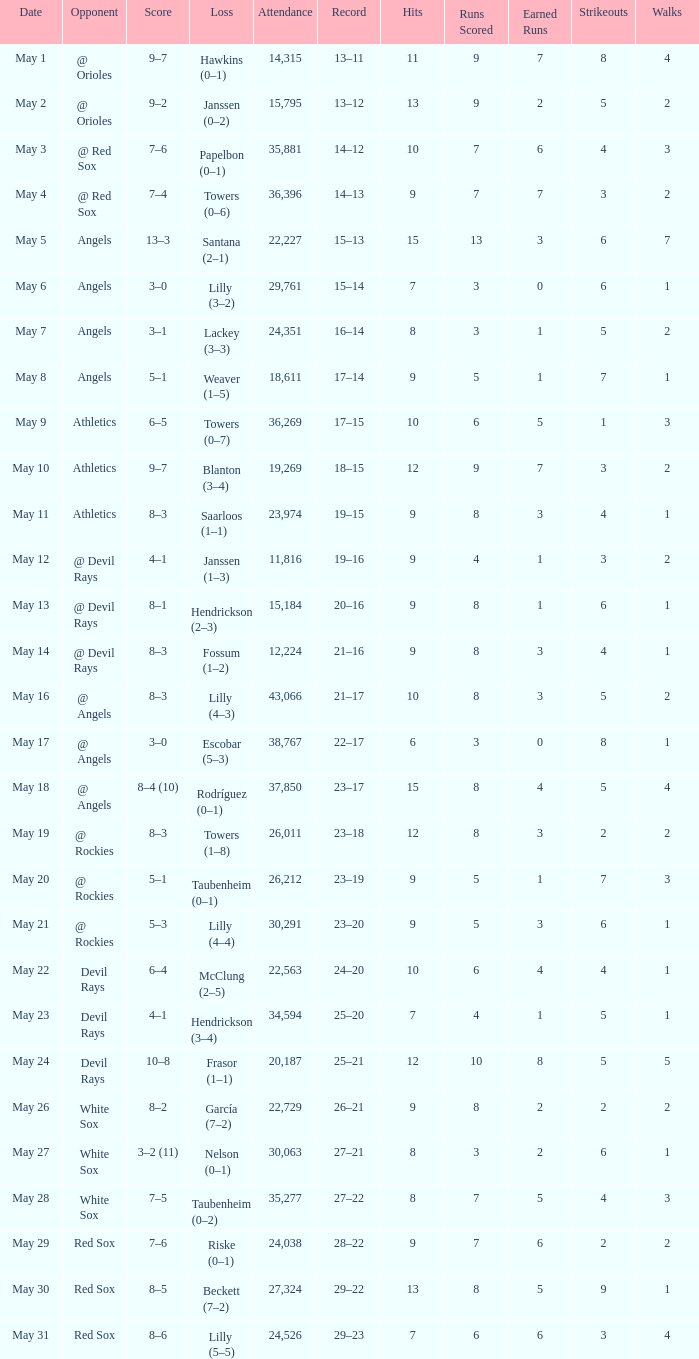When the team had their record of 16–14, what was the total attendance? 1.0. 